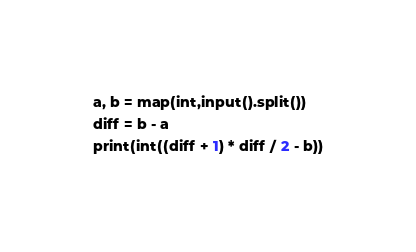Convert code to text. <code><loc_0><loc_0><loc_500><loc_500><_Python_>a, b = map(int,input().split())
diff = b - a
print(int((diff + 1) * diff / 2 - b))</code> 